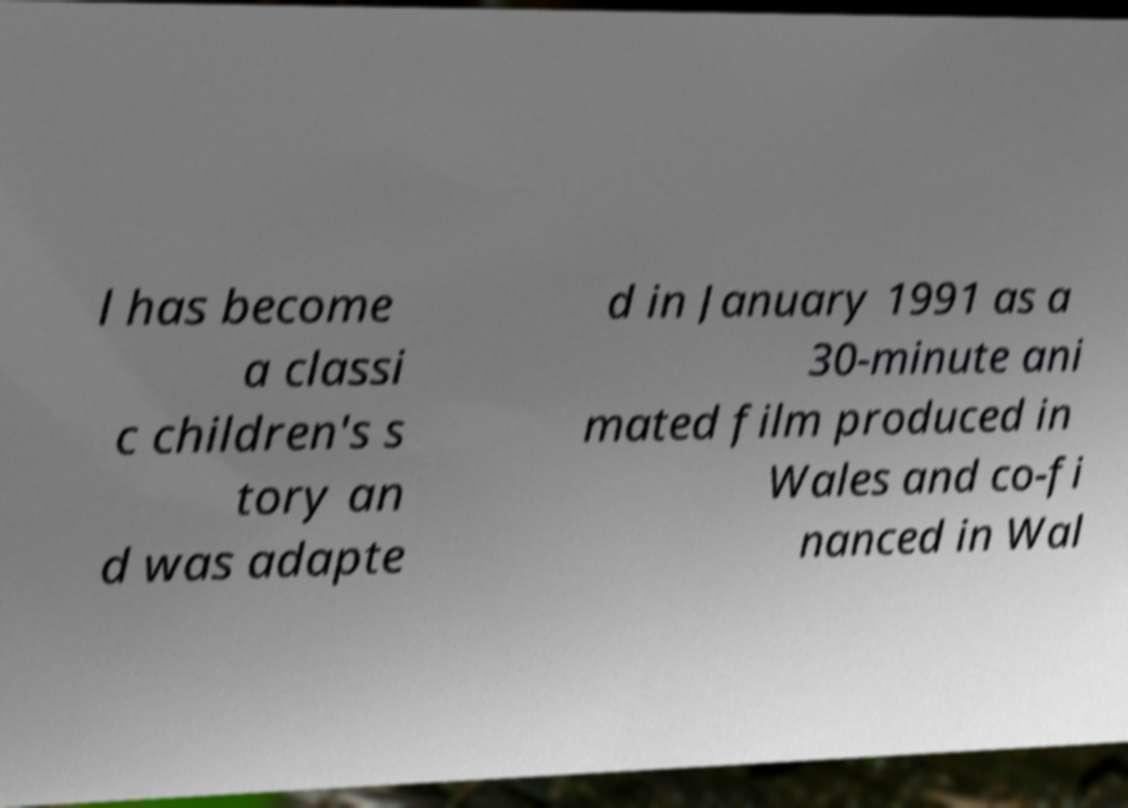For documentation purposes, I need the text within this image transcribed. Could you provide that? l has become a classi c children's s tory an d was adapte d in January 1991 as a 30-minute ani mated film produced in Wales and co-fi nanced in Wal 